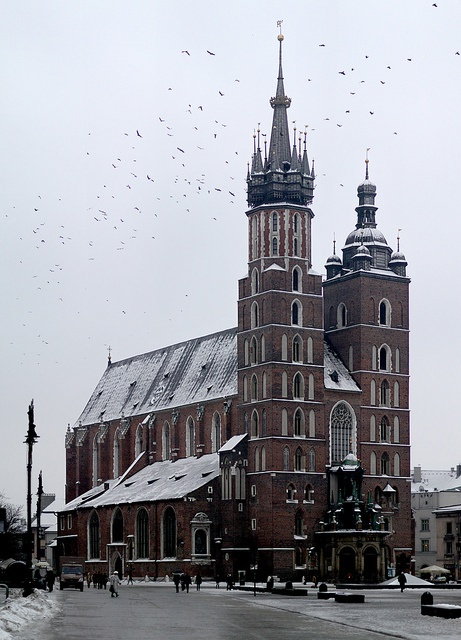Describe the objects in this image and their specific colors. I can see bird in white, lavender, darkgray, and purple tones, truck in white, black, gray, and darkblue tones, people in white, black, darkgray, and gray tones, people in white, black, darkgray, gray, and lightgray tones, and people in white, gray, black, darkgray, and lightgray tones in this image. 